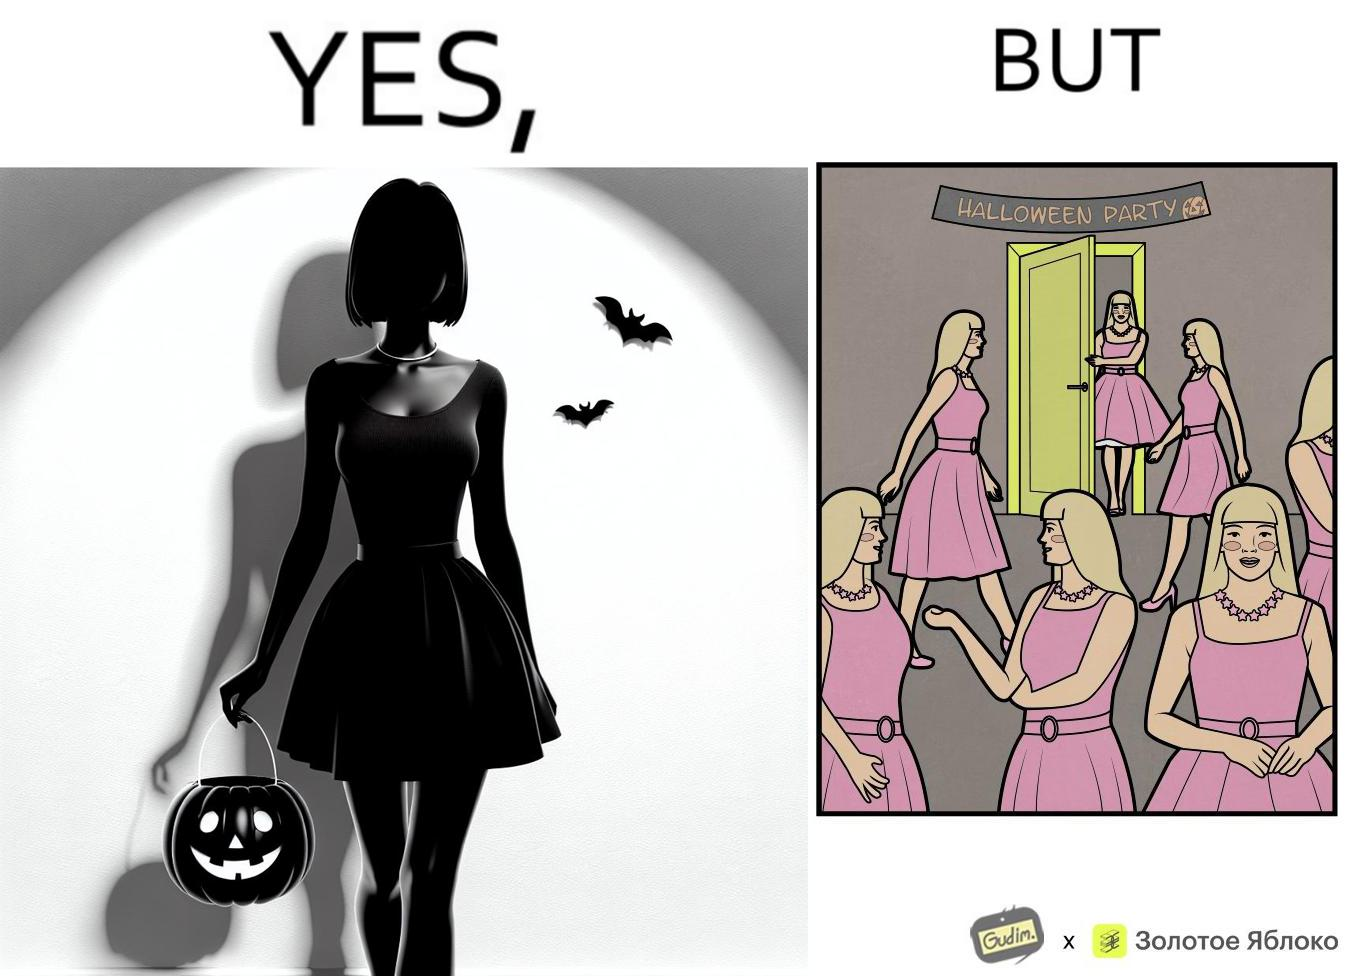Is this a satirical image? Yes, this image is satirical. 